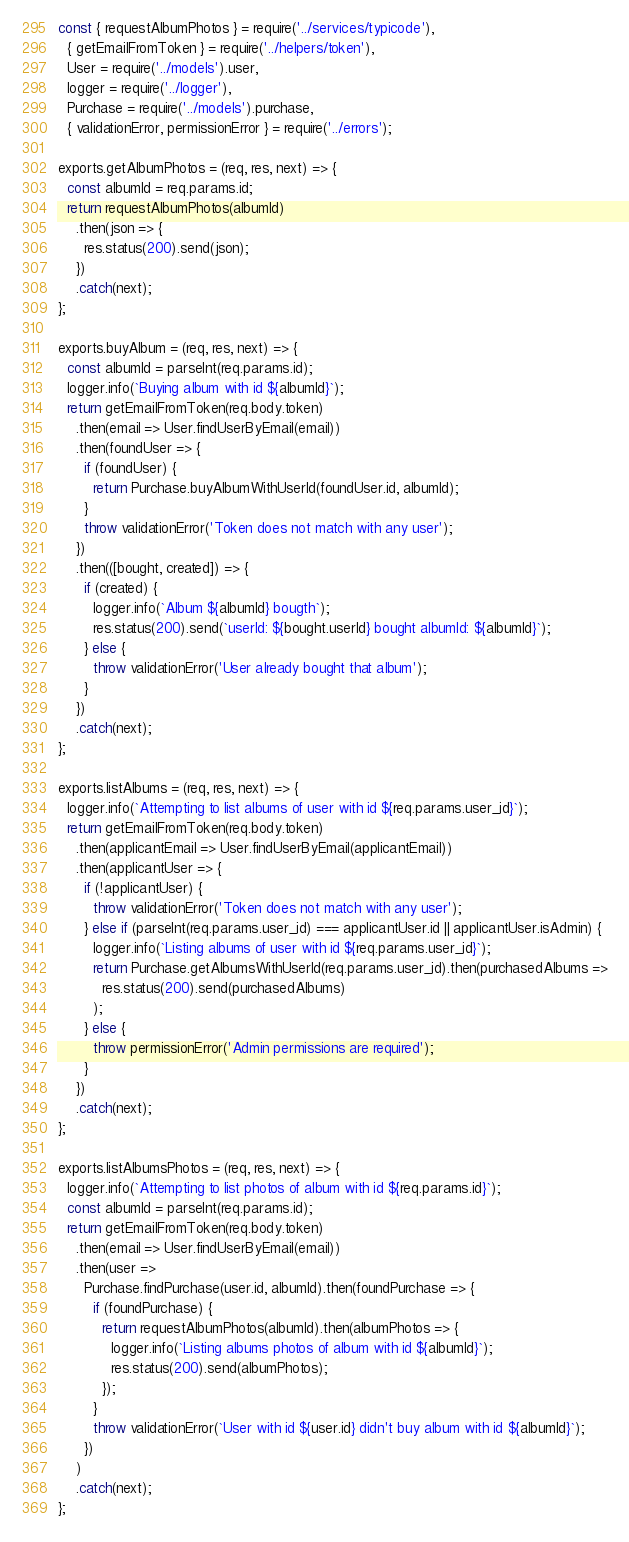<code> <loc_0><loc_0><loc_500><loc_500><_JavaScript_>const { requestAlbumPhotos } = require('../services/typicode'),
  { getEmailFromToken } = require('../helpers/token'),
  User = require('../models').user,
  logger = require('../logger'),
  Purchase = require('../models').purchase,
  { validationError, permissionError } = require('../errors');

exports.getAlbumPhotos = (req, res, next) => {
  const albumId = req.params.id;
  return requestAlbumPhotos(albumId)
    .then(json => {
      res.status(200).send(json);
    })
    .catch(next);
};

exports.buyAlbum = (req, res, next) => {
  const albumId = parseInt(req.params.id);
  logger.info(`Buying album with id ${albumId}`);
  return getEmailFromToken(req.body.token)
    .then(email => User.findUserByEmail(email))
    .then(foundUser => {
      if (foundUser) {
        return Purchase.buyAlbumWithUserId(foundUser.id, albumId);
      }
      throw validationError('Token does not match with any user');
    })
    .then(([bought, created]) => {
      if (created) {
        logger.info(`Album ${albumId} bougth`);
        res.status(200).send(`userId: ${bought.userId} bought albumId: ${albumId}`);
      } else {
        throw validationError('User already bought that album');
      }
    })
    .catch(next);
};

exports.listAlbums = (req, res, next) => {
  logger.info(`Attempting to list albums of user with id ${req.params.user_id}`);
  return getEmailFromToken(req.body.token)
    .then(applicantEmail => User.findUserByEmail(applicantEmail))
    .then(applicantUser => {
      if (!applicantUser) {
        throw validationError('Token does not match with any user');
      } else if (parseInt(req.params.user_id) === applicantUser.id || applicantUser.isAdmin) {
        logger.info(`Listing albums of user with id ${req.params.user_id}`);
        return Purchase.getAlbumsWithUserId(req.params.user_id).then(purchasedAlbums =>
          res.status(200).send(purchasedAlbums)
        );
      } else {
        throw permissionError('Admin permissions are required');
      }
    })
    .catch(next);
};

exports.listAlbumsPhotos = (req, res, next) => {
  logger.info(`Attempting to list photos of album with id ${req.params.id}`);
  const albumId = parseInt(req.params.id);
  return getEmailFromToken(req.body.token)
    .then(email => User.findUserByEmail(email))
    .then(user =>
      Purchase.findPurchase(user.id, albumId).then(foundPurchase => {
        if (foundPurchase) {
          return requestAlbumPhotos(albumId).then(albumPhotos => {
            logger.info(`Listing albums photos of album with id ${albumId}`);
            res.status(200).send(albumPhotos);
          });
        }
        throw validationError(`User with id ${user.id} didn't buy album with id ${albumId}`);
      })
    )
    .catch(next);
};
</code> 